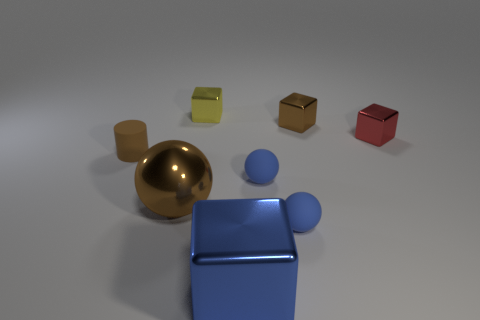There is a block that is the same color as the tiny rubber cylinder; what is its size?
Ensure brevity in your answer.  Small. Do the tiny cylinder and the big ball have the same color?
Offer a terse response. Yes. Are there the same number of small cylinders in front of the brown cylinder and tiny brown rubber things?
Make the answer very short. No. There is a thing that is on the left side of the large cube and right of the large brown metallic object; what shape is it?
Offer a terse response. Cube. There is another large metal object that is the same shape as the yellow thing; what is its color?
Provide a short and direct response. Blue. There is a small brown thing that is to the right of the brown object left of the large object that is behind the big block; what is its shape?
Provide a succinct answer. Cube. There is a ball behind the large brown object; is its size the same as the brown object behind the brown rubber cylinder?
Your response must be concise. Yes. What number of yellow things are the same material as the yellow cube?
Your answer should be compact. 0. How many big shiny objects are on the left side of the large object to the right of the brown ball on the left side of the tiny red metallic object?
Provide a succinct answer. 1. Does the tiny red metallic thing have the same shape as the blue metallic thing?
Give a very brief answer. Yes. 